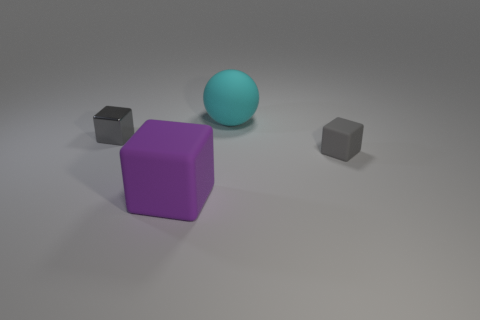What number of other things are there of the same material as the large cube
Ensure brevity in your answer.  2. There is a large object that is in front of the block that is right of the big cyan thing; what shape is it?
Offer a very short reply. Cube. What number of things are either big red balls or shiny objects behind the large purple rubber thing?
Keep it short and to the point. 1. What number of other things are there of the same color as the metal thing?
Offer a terse response. 1. What number of green objects are big spheres or blocks?
Your response must be concise. 0. There is a metallic thing to the left of the small block that is in front of the tiny metal block; are there any tiny gray cubes that are behind it?
Provide a short and direct response. No. Is the color of the metal thing the same as the small rubber object?
Provide a succinct answer. Yes. The large object in front of the small gray block right of the large matte block is what color?
Give a very brief answer. Purple. How many large things are either rubber things or purple cubes?
Offer a terse response. 2. The rubber thing that is in front of the big ball and to the left of the gray rubber block is what color?
Provide a succinct answer. Purple. 